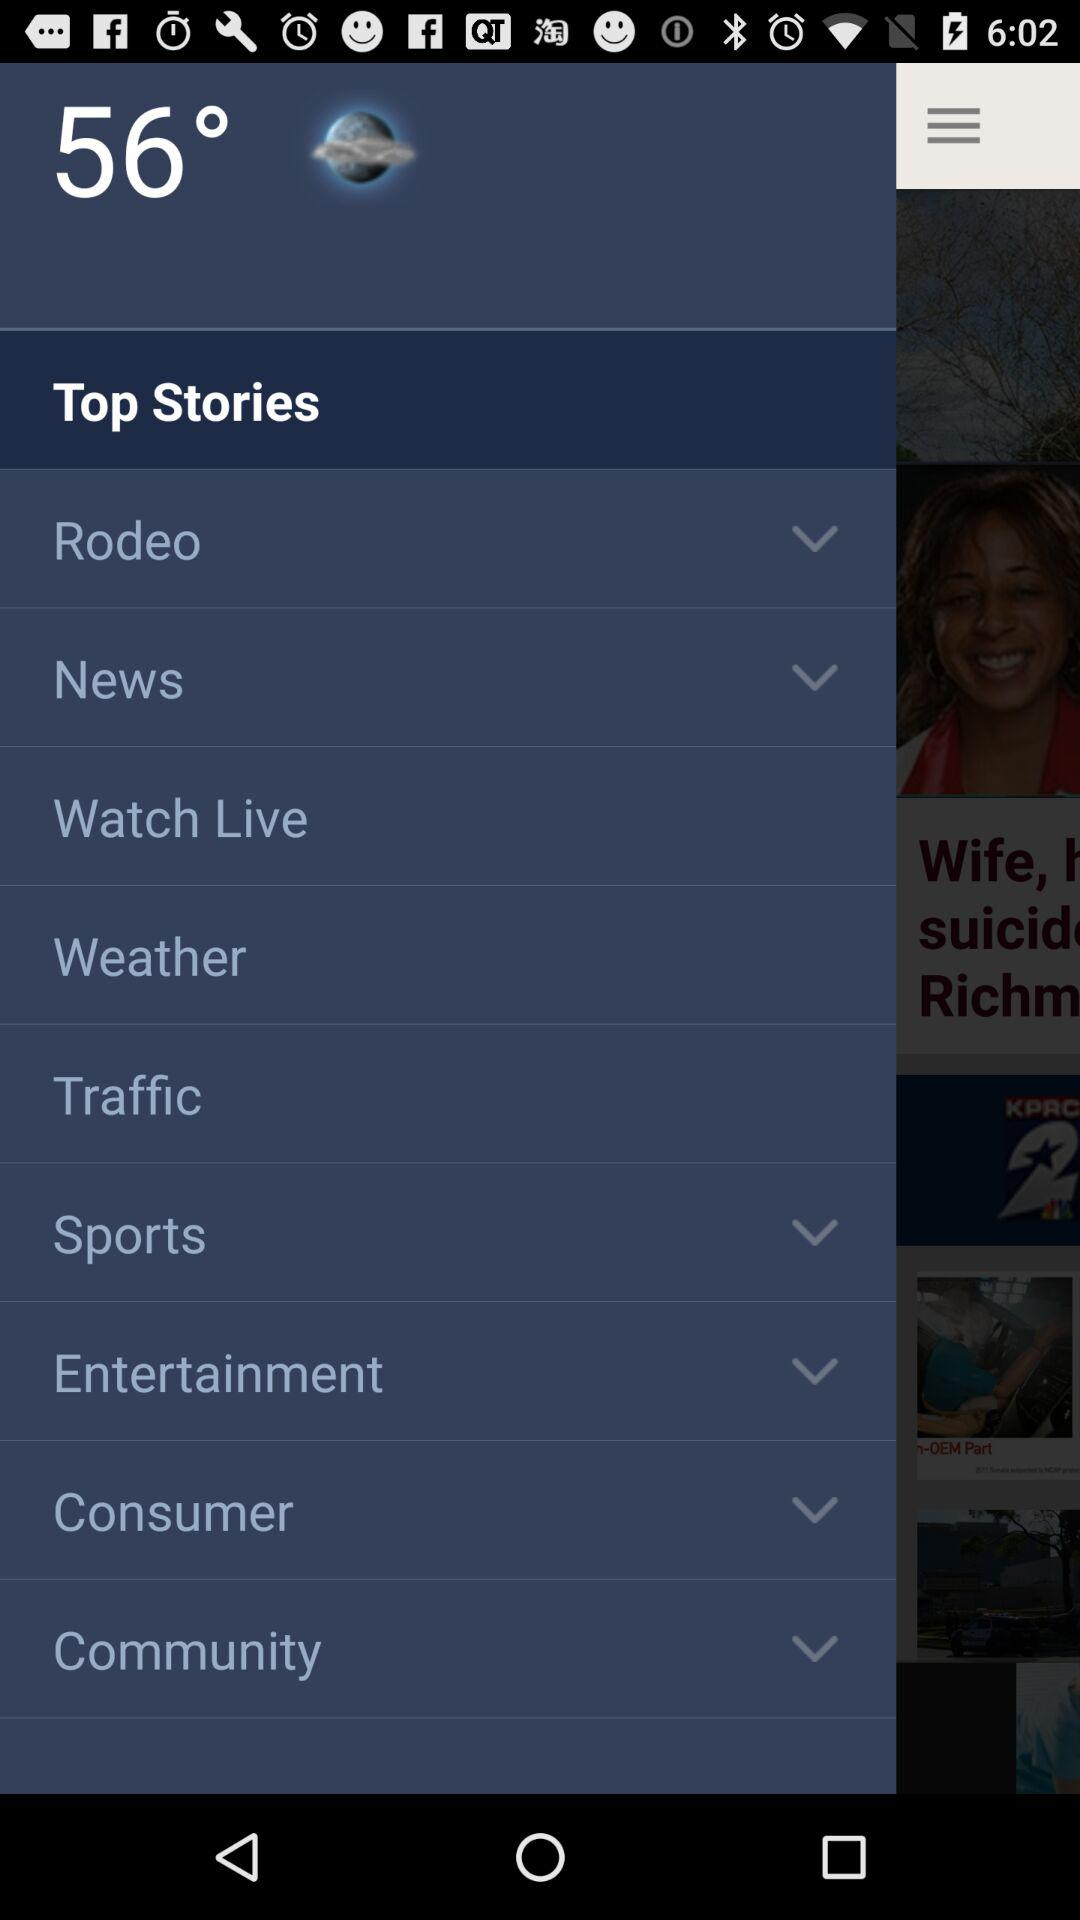What is the given temperature? The given temperature is 56°. 